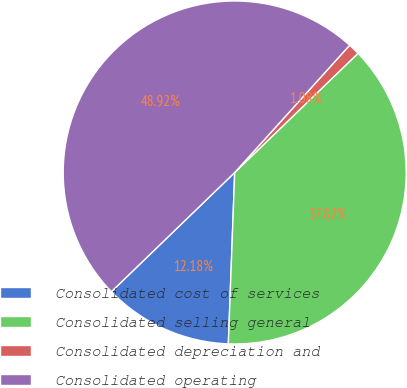Convert chart to OTSL. <chart><loc_0><loc_0><loc_500><loc_500><pie_chart><fcel>Consolidated cost of services<fcel>Consolidated selling general<fcel>Consolidated depreciation and<fcel>Consolidated operating<nl><fcel>12.18%<fcel>37.82%<fcel>1.08%<fcel>48.92%<nl></chart> 